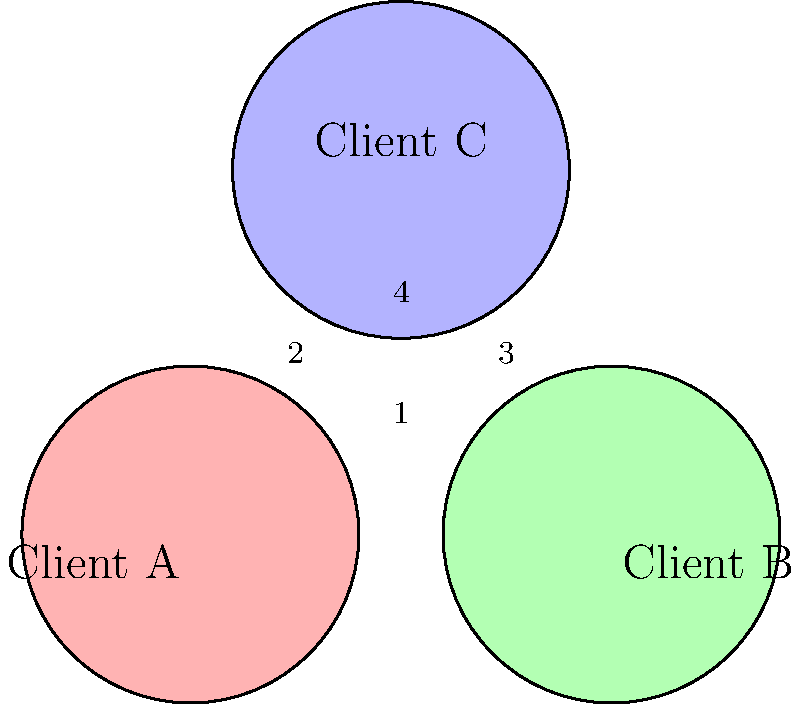In the Venn diagram above, three circles represent different clients (A, B, and C) in a law firm. The overlapping regions indicate shared interests or relationships between clients. Which region represents the area where all three clients have a common interest or relationship, potentially creating the highest risk for a conflict of interest? To answer this question, we need to analyze the Venn diagram and understand the significance of overlapping regions in terms of potential conflicts of interest. Let's break it down step-by-step:

1. Identify the components of the diagram:
   - Three circles represent Clients A, B, and C.
   - Overlapping regions indicate shared interests or relationships.

2. Analyze the overlapping regions:
   - Region 1: Shared interest between Clients A and B only.
   - Region 2: Shared interest between Clients A and C only.
   - Region 3: Shared interest between Clients B and C only.
   - Region 4: Shared interest among all three clients (A, B, and C).

3. Consider the implications of overlapping interests:
   - The more clients involved in a shared interest, the higher the potential for conflicts.
   - A region where all three clients overlap represents the highest risk scenario.

4. Identify the highest risk area:
   - Region 4 is the only area where all three circles intersect.
   - This region represents interests or relationships shared by all three clients.

5. Conclude the significance:
   - Region 4 poses the highest risk for conflicts of interest because any action taken for one client in this area could potentially affect the interests of the other two clients.

Therefore, the region that represents the area where all three clients have a common interest or relationship, creating the highest risk for a conflict of interest, is Region 4.
Answer: Region 4 